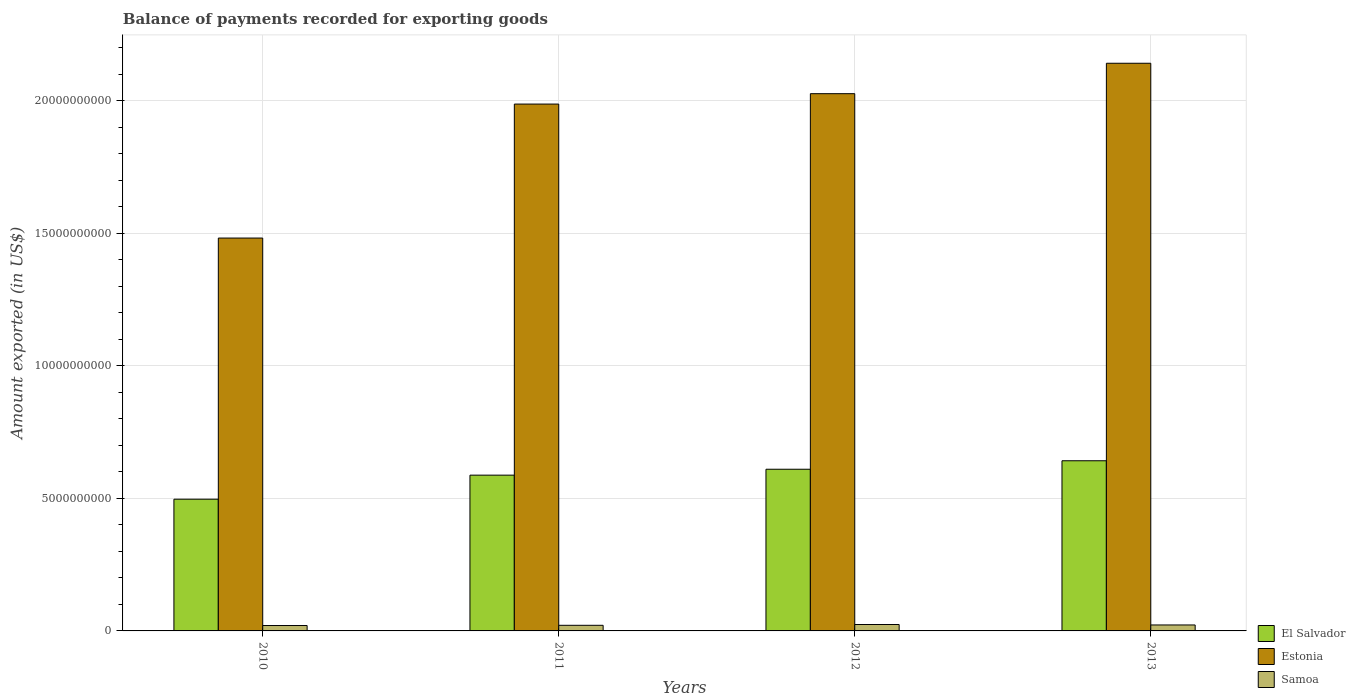How many groups of bars are there?
Your response must be concise. 4. Are the number of bars per tick equal to the number of legend labels?
Ensure brevity in your answer.  Yes. Are the number of bars on each tick of the X-axis equal?
Ensure brevity in your answer.  Yes. How many bars are there on the 2nd tick from the left?
Give a very brief answer. 3. How many bars are there on the 1st tick from the right?
Your answer should be very brief. 3. In how many cases, is the number of bars for a given year not equal to the number of legend labels?
Offer a very short reply. 0. What is the amount exported in El Salvador in 2011?
Make the answer very short. 5.88e+09. Across all years, what is the maximum amount exported in Estonia?
Offer a terse response. 2.14e+1. Across all years, what is the minimum amount exported in Samoa?
Your answer should be very brief. 2.04e+08. What is the total amount exported in Samoa in the graph?
Make the answer very short. 8.83e+08. What is the difference between the amount exported in Estonia in 2010 and that in 2012?
Provide a succinct answer. -5.45e+09. What is the difference between the amount exported in Samoa in 2010 and the amount exported in El Salvador in 2013?
Offer a terse response. -6.22e+09. What is the average amount exported in Samoa per year?
Make the answer very short. 2.21e+08. In the year 2011, what is the difference between the amount exported in Estonia and amount exported in Samoa?
Offer a very short reply. 1.97e+1. What is the ratio of the amount exported in Estonia in 2010 to that in 2013?
Make the answer very short. 0.69. Is the amount exported in El Salvador in 2010 less than that in 2011?
Offer a terse response. Yes. Is the difference between the amount exported in Estonia in 2010 and 2012 greater than the difference between the amount exported in Samoa in 2010 and 2012?
Give a very brief answer. No. What is the difference between the highest and the second highest amount exported in Samoa?
Provide a succinct answer. 1.70e+07. What is the difference between the highest and the lowest amount exported in Estonia?
Provide a succinct answer. 6.60e+09. What does the 3rd bar from the left in 2010 represents?
Offer a very short reply. Samoa. What does the 1st bar from the right in 2011 represents?
Ensure brevity in your answer.  Samoa. Is it the case that in every year, the sum of the amount exported in Estonia and amount exported in Samoa is greater than the amount exported in El Salvador?
Offer a terse response. Yes. What is the difference between two consecutive major ticks on the Y-axis?
Give a very brief answer. 5.00e+09. Are the values on the major ticks of Y-axis written in scientific E-notation?
Your answer should be very brief. No. Does the graph contain any zero values?
Provide a succinct answer. No. Does the graph contain grids?
Make the answer very short. Yes. How many legend labels are there?
Make the answer very short. 3. What is the title of the graph?
Your answer should be compact. Balance of payments recorded for exporting goods. Does "Malaysia" appear as one of the legend labels in the graph?
Keep it short and to the point. No. What is the label or title of the Y-axis?
Your answer should be very brief. Amount exported (in US$). What is the Amount exported (in US$) of El Salvador in 2010?
Provide a short and direct response. 4.97e+09. What is the Amount exported (in US$) of Estonia in 2010?
Your answer should be very brief. 1.48e+1. What is the Amount exported (in US$) of Samoa in 2010?
Make the answer very short. 2.04e+08. What is the Amount exported (in US$) in El Salvador in 2011?
Make the answer very short. 5.88e+09. What is the Amount exported (in US$) in Estonia in 2011?
Your answer should be compact. 1.99e+1. What is the Amount exported (in US$) of Samoa in 2011?
Your response must be concise. 2.12e+08. What is the Amount exported (in US$) of El Salvador in 2012?
Offer a very short reply. 6.10e+09. What is the Amount exported (in US$) in Estonia in 2012?
Offer a terse response. 2.03e+1. What is the Amount exported (in US$) in Samoa in 2012?
Make the answer very short. 2.42e+08. What is the Amount exported (in US$) of El Salvador in 2013?
Your response must be concise. 6.42e+09. What is the Amount exported (in US$) in Estonia in 2013?
Provide a succinct answer. 2.14e+1. What is the Amount exported (in US$) of Samoa in 2013?
Give a very brief answer. 2.25e+08. Across all years, what is the maximum Amount exported (in US$) in El Salvador?
Provide a succinct answer. 6.42e+09. Across all years, what is the maximum Amount exported (in US$) of Estonia?
Your answer should be very brief. 2.14e+1. Across all years, what is the maximum Amount exported (in US$) in Samoa?
Keep it short and to the point. 2.42e+08. Across all years, what is the minimum Amount exported (in US$) of El Salvador?
Make the answer very short. 4.97e+09. Across all years, what is the minimum Amount exported (in US$) of Estonia?
Your answer should be very brief. 1.48e+1. Across all years, what is the minimum Amount exported (in US$) of Samoa?
Give a very brief answer. 2.04e+08. What is the total Amount exported (in US$) of El Salvador in the graph?
Ensure brevity in your answer.  2.34e+1. What is the total Amount exported (in US$) in Estonia in the graph?
Offer a very short reply. 7.64e+1. What is the total Amount exported (in US$) in Samoa in the graph?
Your response must be concise. 8.83e+08. What is the difference between the Amount exported (in US$) of El Salvador in 2010 and that in 2011?
Provide a succinct answer. -9.07e+08. What is the difference between the Amount exported (in US$) in Estonia in 2010 and that in 2011?
Give a very brief answer. -5.06e+09. What is the difference between the Amount exported (in US$) of Samoa in 2010 and that in 2011?
Ensure brevity in your answer.  -8.14e+06. What is the difference between the Amount exported (in US$) in El Salvador in 2010 and that in 2012?
Your answer should be very brief. -1.13e+09. What is the difference between the Amount exported (in US$) in Estonia in 2010 and that in 2012?
Give a very brief answer. -5.45e+09. What is the difference between the Amount exported (in US$) in Samoa in 2010 and that in 2012?
Provide a short and direct response. -3.86e+07. What is the difference between the Amount exported (in US$) of El Salvador in 2010 and that in 2013?
Provide a succinct answer. -1.45e+09. What is the difference between the Amount exported (in US$) of Estonia in 2010 and that in 2013?
Your response must be concise. -6.60e+09. What is the difference between the Amount exported (in US$) of Samoa in 2010 and that in 2013?
Ensure brevity in your answer.  -2.16e+07. What is the difference between the Amount exported (in US$) of El Salvador in 2011 and that in 2012?
Your response must be concise. -2.23e+08. What is the difference between the Amount exported (in US$) in Estonia in 2011 and that in 2012?
Keep it short and to the point. -3.92e+08. What is the difference between the Amount exported (in US$) in Samoa in 2011 and that in 2012?
Your response must be concise. -3.05e+07. What is the difference between the Amount exported (in US$) in El Salvador in 2011 and that in 2013?
Ensure brevity in your answer.  -5.43e+08. What is the difference between the Amount exported (in US$) of Estonia in 2011 and that in 2013?
Make the answer very short. -1.54e+09. What is the difference between the Amount exported (in US$) of Samoa in 2011 and that in 2013?
Your response must be concise. -1.34e+07. What is the difference between the Amount exported (in US$) of El Salvador in 2012 and that in 2013?
Make the answer very short. -3.20e+08. What is the difference between the Amount exported (in US$) of Estonia in 2012 and that in 2013?
Provide a short and direct response. -1.15e+09. What is the difference between the Amount exported (in US$) of Samoa in 2012 and that in 2013?
Your response must be concise. 1.70e+07. What is the difference between the Amount exported (in US$) of El Salvador in 2010 and the Amount exported (in US$) of Estonia in 2011?
Keep it short and to the point. -1.49e+1. What is the difference between the Amount exported (in US$) in El Salvador in 2010 and the Amount exported (in US$) in Samoa in 2011?
Give a very brief answer. 4.76e+09. What is the difference between the Amount exported (in US$) in Estonia in 2010 and the Amount exported (in US$) in Samoa in 2011?
Give a very brief answer. 1.46e+1. What is the difference between the Amount exported (in US$) in El Salvador in 2010 and the Amount exported (in US$) in Estonia in 2012?
Ensure brevity in your answer.  -1.53e+1. What is the difference between the Amount exported (in US$) in El Salvador in 2010 and the Amount exported (in US$) in Samoa in 2012?
Offer a terse response. 4.73e+09. What is the difference between the Amount exported (in US$) of Estonia in 2010 and the Amount exported (in US$) of Samoa in 2012?
Provide a succinct answer. 1.46e+1. What is the difference between the Amount exported (in US$) in El Salvador in 2010 and the Amount exported (in US$) in Estonia in 2013?
Make the answer very short. -1.65e+1. What is the difference between the Amount exported (in US$) of El Salvador in 2010 and the Amount exported (in US$) of Samoa in 2013?
Offer a terse response. 4.75e+09. What is the difference between the Amount exported (in US$) in Estonia in 2010 and the Amount exported (in US$) in Samoa in 2013?
Provide a succinct answer. 1.46e+1. What is the difference between the Amount exported (in US$) in El Salvador in 2011 and the Amount exported (in US$) in Estonia in 2012?
Your answer should be compact. -1.44e+1. What is the difference between the Amount exported (in US$) of El Salvador in 2011 and the Amount exported (in US$) of Samoa in 2012?
Provide a short and direct response. 5.64e+09. What is the difference between the Amount exported (in US$) of Estonia in 2011 and the Amount exported (in US$) of Samoa in 2012?
Provide a succinct answer. 1.96e+1. What is the difference between the Amount exported (in US$) in El Salvador in 2011 and the Amount exported (in US$) in Estonia in 2013?
Provide a short and direct response. -1.55e+1. What is the difference between the Amount exported (in US$) in El Salvador in 2011 and the Amount exported (in US$) in Samoa in 2013?
Offer a terse response. 5.65e+09. What is the difference between the Amount exported (in US$) of Estonia in 2011 and the Amount exported (in US$) of Samoa in 2013?
Offer a very short reply. 1.97e+1. What is the difference between the Amount exported (in US$) of El Salvador in 2012 and the Amount exported (in US$) of Estonia in 2013?
Offer a very short reply. -1.53e+1. What is the difference between the Amount exported (in US$) of El Salvador in 2012 and the Amount exported (in US$) of Samoa in 2013?
Your answer should be compact. 5.88e+09. What is the difference between the Amount exported (in US$) of Estonia in 2012 and the Amount exported (in US$) of Samoa in 2013?
Offer a terse response. 2.00e+1. What is the average Amount exported (in US$) in El Salvador per year?
Your response must be concise. 5.84e+09. What is the average Amount exported (in US$) in Estonia per year?
Give a very brief answer. 1.91e+1. What is the average Amount exported (in US$) of Samoa per year?
Provide a succinct answer. 2.21e+08. In the year 2010, what is the difference between the Amount exported (in US$) in El Salvador and Amount exported (in US$) in Estonia?
Give a very brief answer. -9.85e+09. In the year 2010, what is the difference between the Amount exported (in US$) of El Salvador and Amount exported (in US$) of Samoa?
Give a very brief answer. 4.77e+09. In the year 2010, what is the difference between the Amount exported (in US$) in Estonia and Amount exported (in US$) in Samoa?
Offer a very short reply. 1.46e+1. In the year 2011, what is the difference between the Amount exported (in US$) of El Salvador and Amount exported (in US$) of Estonia?
Ensure brevity in your answer.  -1.40e+1. In the year 2011, what is the difference between the Amount exported (in US$) of El Salvador and Amount exported (in US$) of Samoa?
Your answer should be compact. 5.67e+09. In the year 2011, what is the difference between the Amount exported (in US$) in Estonia and Amount exported (in US$) in Samoa?
Offer a terse response. 1.97e+1. In the year 2012, what is the difference between the Amount exported (in US$) of El Salvador and Amount exported (in US$) of Estonia?
Your answer should be compact. -1.42e+1. In the year 2012, what is the difference between the Amount exported (in US$) in El Salvador and Amount exported (in US$) in Samoa?
Your response must be concise. 5.86e+09. In the year 2012, what is the difference between the Amount exported (in US$) of Estonia and Amount exported (in US$) of Samoa?
Offer a very short reply. 2.00e+1. In the year 2013, what is the difference between the Amount exported (in US$) in El Salvador and Amount exported (in US$) in Estonia?
Provide a succinct answer. -1.50e+1. In the year 2013, what is the difference between the Amount exported (in US$) of El Salvador and Amount exported (in US$) of Samoa?
Make the answer very short. 6.20e+09. In the year 2013, what is the difference between the Amount exported (in US$) in Estonia and Amount exported (in US$) in Samoa?
Give a very brief answer. 2.12e+1. What is the ratio of the Amount exported (in US$) in El Salvador in 2010 to that in 2011?
Provide a short and direct response. 0.85. What is the ratio of the Amount exported (in US$) in Estonia in 2010 to that in 2011?
Provide a short and direct response. 0.75. What is the ratio of the Amount exported (in US$) of Samoa in 2010 to that in 2011?
Offer a very short reply. 0.96. What is the ratio of the Amount exported (in US$) of El Salvador in 2010 to that in 2012?
Offer a terse response. 0.81. What is the ratio of the Amount exported (in US$) in Estonia in 2010 to that in 2012?
Provide a short and direct response. 0.73. What is the ratio of the Amount exported (in US$) of Samoa in 2010 to that in 2012?
Your response must be concise. 0.84. What is the ratio of the Amount exported (in US$) in El Salvador in 2010 to that in 2013?
Make the answer very short. 0.77. What is the ratio of the Amount exported (in US$) in Estonia in 2010 to that in 2013?
Give a very brief answer. 0.69. What is the ratio of the Amount exported (in US$) in Samoa in 2010 to that in 2013?
Your answer should be compact. 0.9. What is the ratio of the Amount exported (in US$) in El Salvador in 2011 to that in 2012?
Offer a very short reply. 0.96. What is the ratio of the Amount exported (in US$) in Estonia in 2011 to that in 2012?
Your answer should be very brief. 0.98. What is the ratio of the Amount exported (in US$) of Samoa in 2011 to that in 2012?
Provide a succinct answer. 0.87. What is the ratio of the Amount exported (in US$) in El Salvador in 2011 to that in 2013?
Offer a terse response. 0.92. What is the ratio of the Amount exported (in US$) in Estonia in 2011 to that in 2013?
Ensure brevity in your answer.  0.93. What is the ratio of the Amount exported (in US$) in Samoa in 2011 to that in 2013?
Your response must be concise. 0.94. What is the ratio of the Amount exported (in US$) of El Salvador in 2012 to that in 2013?
Your answer should be compact. 0.95. What is the ratio of the Amount exported (in US$) in Estonia in 2012 to that in 2013?
Offer a terse response. 0.95. What is the ratio of the Amount exported (in US$) of Samoa in 2012 to that in 2013?
Offer a terse response. 1.08. What is the difference between the highest and the second highest Amount exported (in US$) of El Salvador?
Provide a succinct answer. 3.20e+08. What is the difference between the highest and the second highest Amount exported (in US$) in Estonia?
Your response must be concise. 1.15e+09. What is the difference between the highest and the second highest Amount exported (in US$) in Samoa?
Provide a succinct answer. 1.70e+07. What is the difference between the highest and the lowest Amount exported (in US$) of El Salvador?
Your response must be concise. 1.45e+09. What is the difference between the highest and the lowest Amount exported (in US$) of Estonia?
Provide a succinct answer. 6.60e+09. What is the difference between the highest and the lowest Amount exported (in US$) of Samoa?
Ensure brevity in your answer.  3.86e+07. 